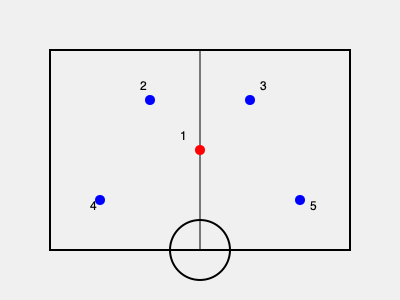Based on the basketball court layout shown, which offensive formation is being depicted, and how might this setup benefit the team's scoring opportunities? To analyze the formation and its potential benefits, let's break it down step-by-step:

1. Player positions:
   - Player 1 (red) is at the top of the key
   - Players 2 and 3 are positioned at the wings
   - Players 4 and 5 are in the corners

2. Formation identification:
   This setup represents a "5-out" or "5-open" offensive formation. All five players are positioned outside the three-point line, creating maximum spacing.

3. Benefits of this formation:
   a) Spacing: With all players outside the paint, it creates more room for drives and cuts.
   b) Three-point opportunities: All players are in position for catch-and-shoot three-pointers.
   c) Driving lanes: The open paint allows for easier penetration by the ball handler.
   d) Defensive stretching: Forces the defense to guard the perimeter, potentially creating mismatches.

4. Scoring opportunities:
   a) Pick and pop: Player 1 can use screens from perimeter players for open shots or drives.
   b) Drive and kick: Penetration by any player can lead to open three-point shots.
   c) Backdoor cuts: With the defense stretched, quick cuts to the basket become more effective.
   d) Isolation: Skilled players can take advantage of one-on-one matchups.

5. Adaptability:
   This formation can quickly transition into other setups like pick-and-roll or off-ball screening actions.

In summary, this "5-out" formation maximizes spacing and creates various scoring opportunities through perimeter shooting, driving lanes, and strategic player movement.
Answer: 5-out formation; maximizes spacing for drives, three-pointers, and versatile offensive options. 